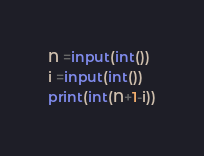<code> <loc_0><loc_0><loc_500><loc_500><_Python_>N =input(int())
i =input(int())
print(int(N+1-i))</code> 